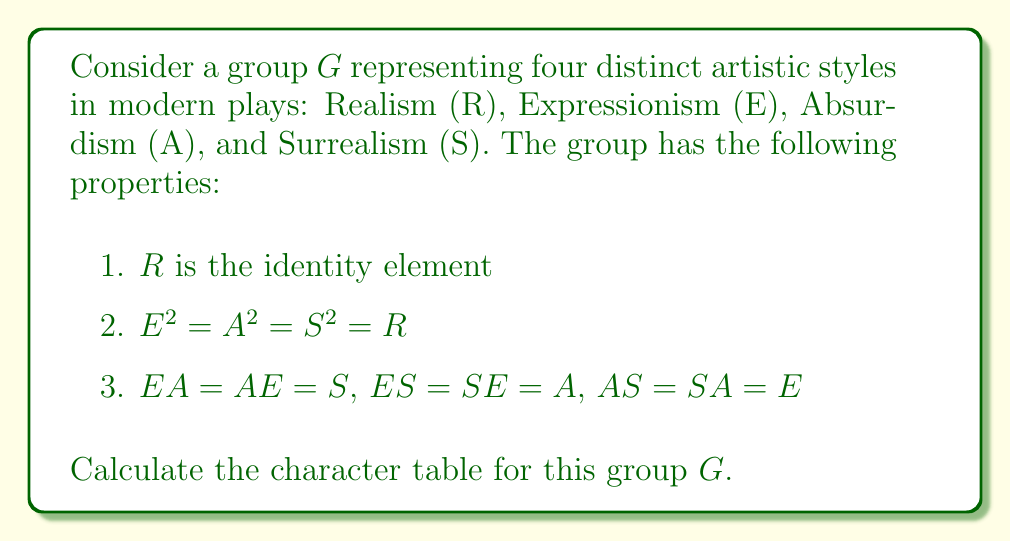Could you help me with this problem? To calculate the character table for this group, we'll follow these steps:

1. Determine the order of the group:
   The group has 4 elements: $G = \{R, E, A, S\}$, so $|G| = 4$.

2. Identify the conjugacy classes:
   Since $G$ is abelian (all elements commute), each element forms its own conjugacy class:
   $\{R\}, \{E\}, \{A\}, \{S\}$

3. Determine the number of irreducible representations:
   The number of irreducible representations equals the number of conjugacy classes, which is 4.

4. Find the dimensions of the irreducible representations:
   For an abelian group, all irreducible representations are 1-dimensional.

5. Construct the character table:
   - The first row and column represent the identity element and the trivial representation, respectively.
   - For abelian groups, characters are homomorphisms from $G$ to $\mathbb{C}^*$.
   - Let $\omega = e^{2\pi i/4} = i$ be a primitive 4th root of unity.

   The character table will have the form:

   $$
   \begin{array}{c|cccc}
    & R & E & A & S \\
   \hline
   \chi_1 & 1 & 1 & 1 & 1 \\
   \chi_2 & 1 & 1 & -1 & -1 \\
   \chi_3 & 1 & -1 & 1 & -1 \\
   \chi_4 & 1 & -1 & -1 & 1
   \end{array}
   $$

   Here, $\chi_1$ is the trivial representation, and $\chi_2, \chi_3, \chi_4$ are constructed to ensure orthogonality and to respect the group structure (e.g., $\chi(E^2) = \chi(E)^2 = 1$ for all characters).
Answer: $$
\begin{array}{c|cccc}
 & R & E & A & S \\
\hline
\chi_1 & 1 & 1 & 1 & 1 \\
\chi_2 & 1 & 1 & -1 & -1 \\
\chi_3 & 1 & -1 & 1 & -1 \\
\chi_4 & 1 & -1 & -1 & 1
\end{array}
$$ 